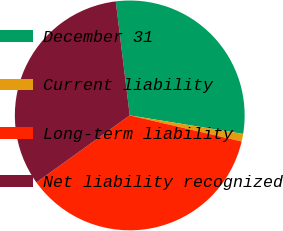Convert chart. <chart><loc_0><loc_0><loc_500><loc_500><pie_chart><fcel>December 31<fcel>Current liability<fcel>Long-term liability<fcel>Net liability recognized<nl><fcel>29.52%<fcel>1.07%<fcel>36.44%<fcel>32.98%<nl></chart> 